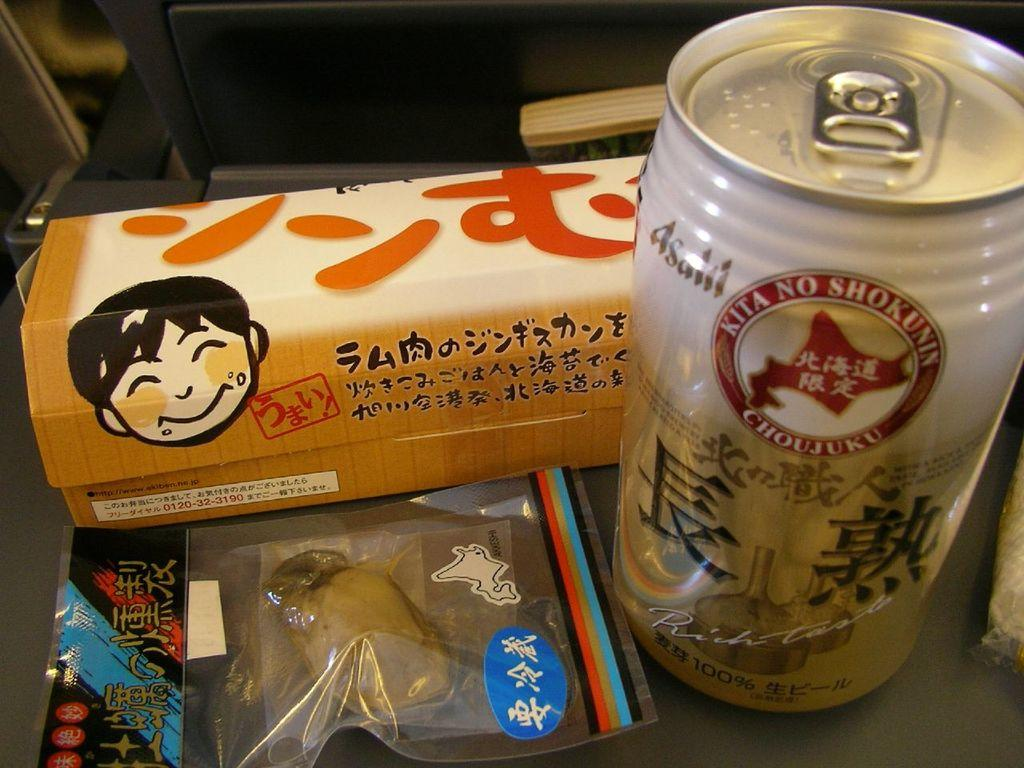Provide a one-sentence caption for the provided image. Japanese snacks and drink including Asailil can which says Kita No Shokunin on the side. 